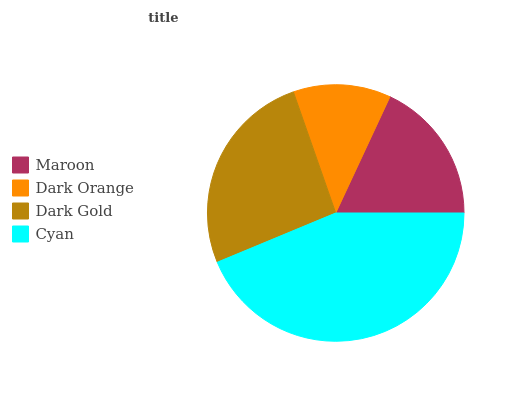Is Dark Orange the minimum?
Answer yes or no. Yes. Is Cyan the maximum?
Answer yes or no. Yes. Is Dark Gold the minimum?
Answer yes or no. No. Is Dark Gold the maximum?
Answer yes or no. No. Is Dark Gold greater than Dark Orange?
Answer yes or no. Yes. Is Dark Orange less than Dark Gold?
Answer yes or no. Yes. Is Dark Orange greater than Dark Gold?
Answer yes or no. No. Is Dark Gold less than Dark Orange?
Answer yes or no. No. Is Dark Gold the high median?
Answer yes or no. Yes. Is Maroon the low median?
Answer yes or no. Yes. Is Cyan the high median?
Answer yes or no. No. Is Dark Gold the low median?
Answer yes or no. No. 